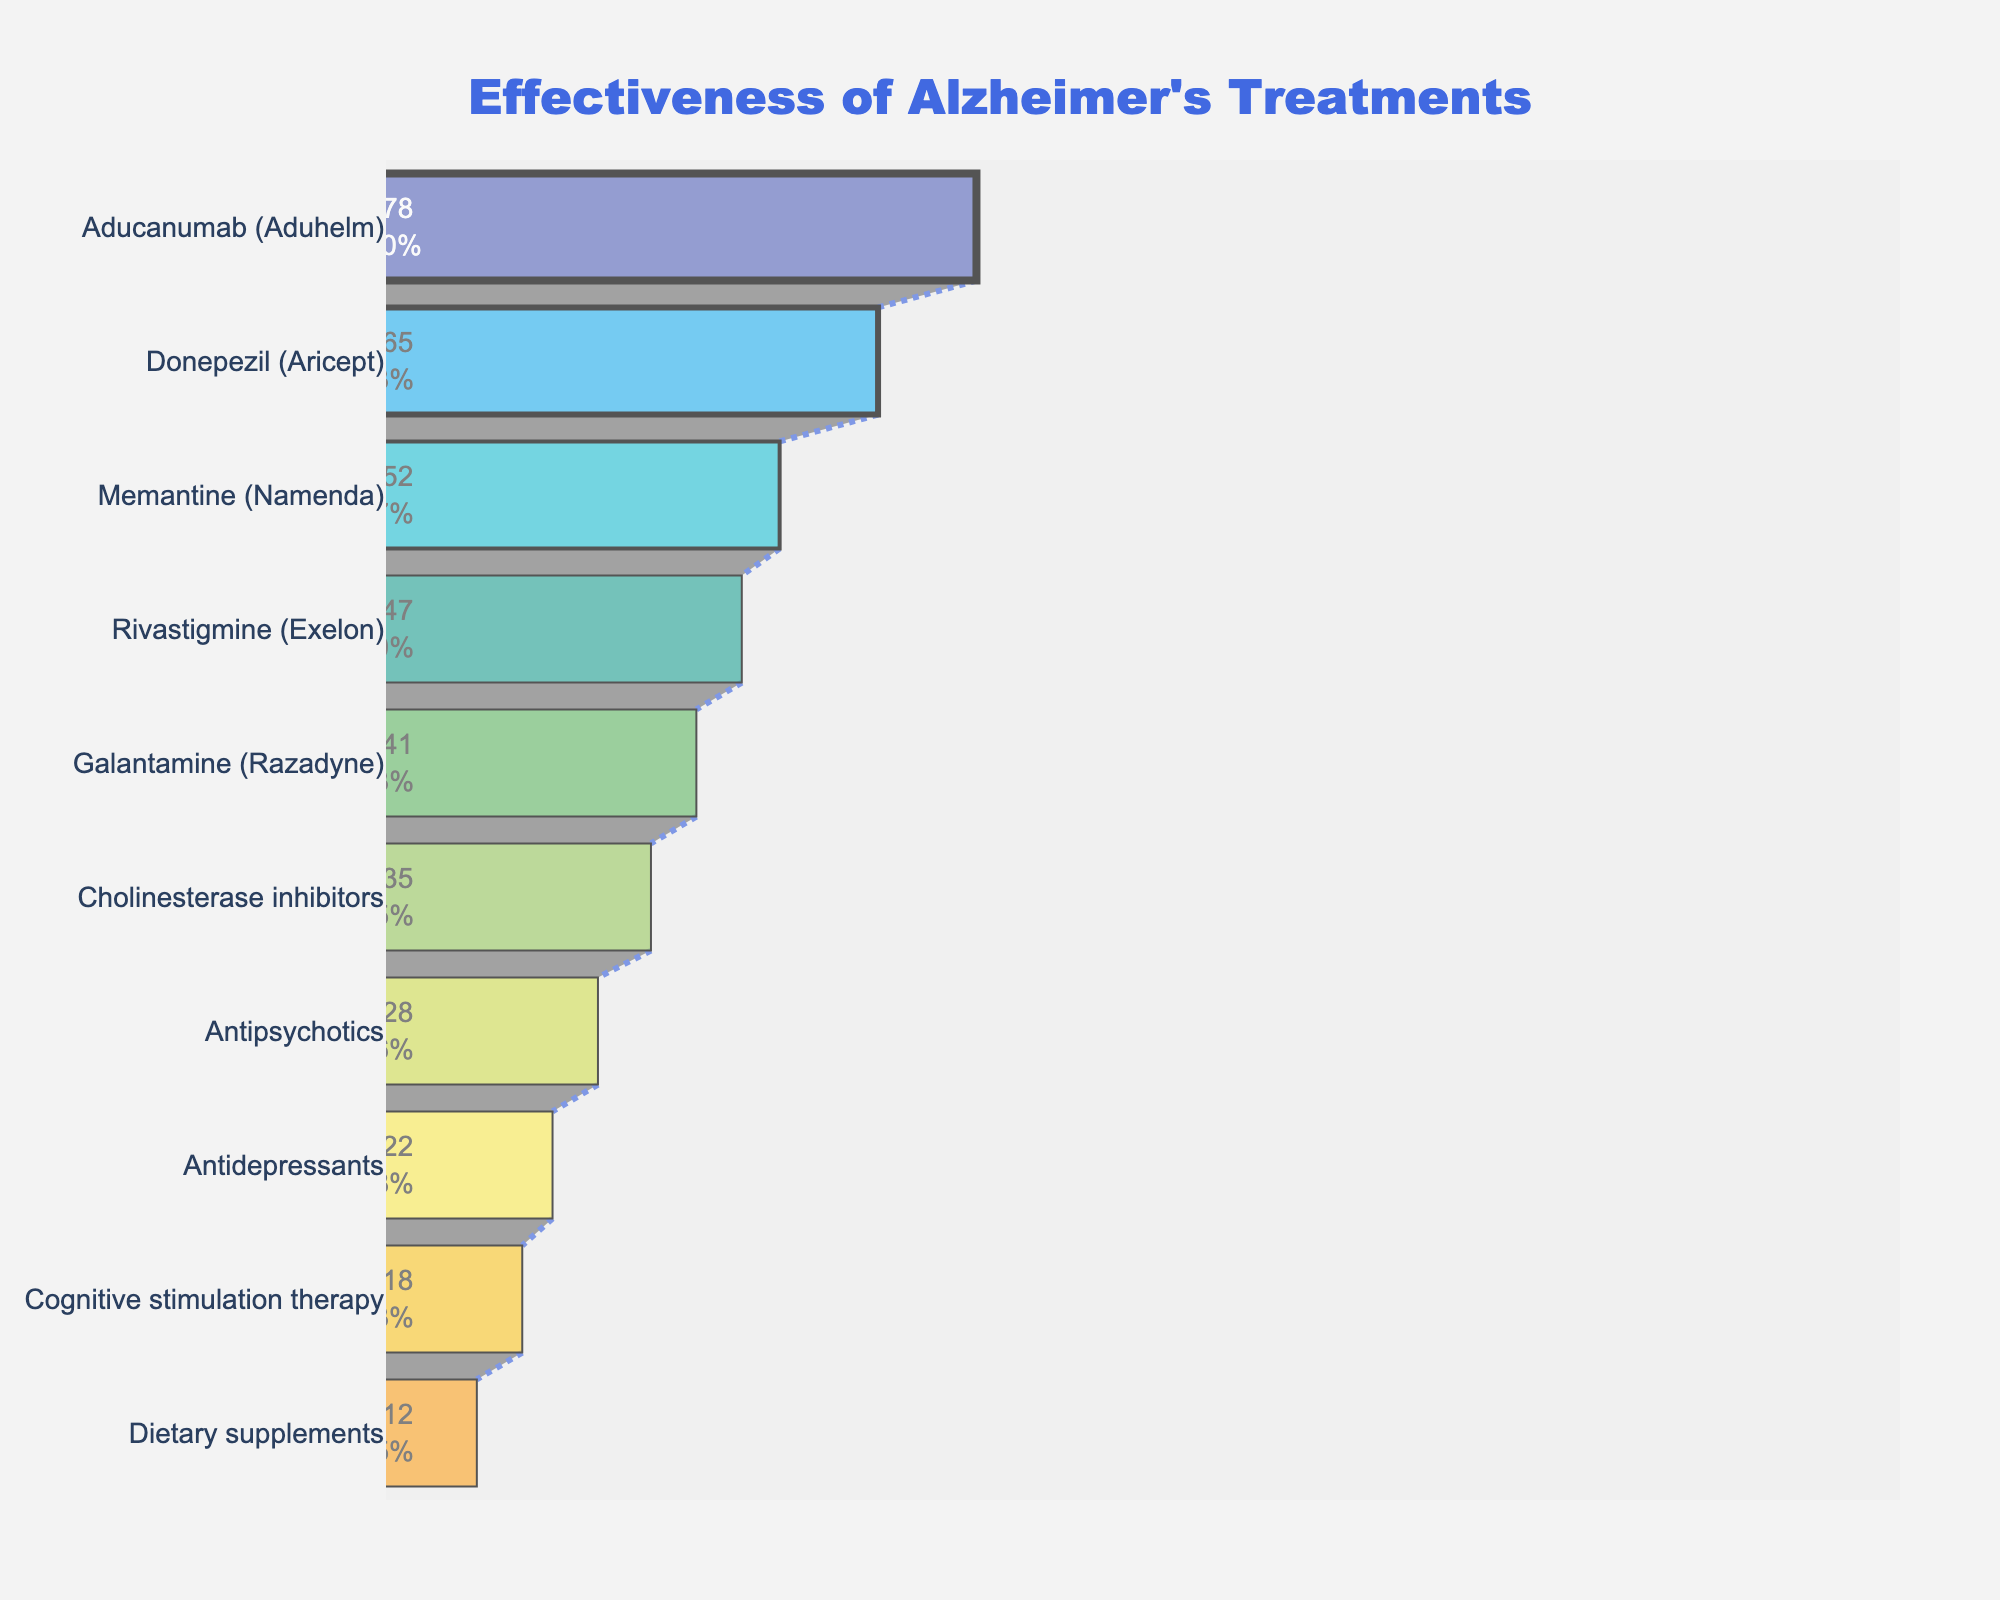Which Alzheimer's treatment has the highest success rate? The funnel chart shows the success rates of various Alzheimer's treatments, with the highest success rate at the top of the chart. Aducanumab (Aduhelm) is at the top.
Answer: Aducanumab (Aduhelm) What is the success rate of Donepezil (Aricept)? The funnel chart lists the success rates next to each treatment. Donepezil (Aricept) is the second treatment in the chart, with a success rate of 0.65 or 65%.
Answer: 65% How do the success rates of Memantine (Namenda) and Rivastigmine (Exelon) compare? By examining the chart, we can see Memantine (Namenda) has a success rate of 52% and Rivastigmine (Exelon) has a success rate of 47%. Comparing these values, Memantine has a higher success rate than Rivastigmine.
Answer: Memantine (Namenda) has a higher success rate Which treatments have a success rate of less than 30%? By scanning the funnel chart, treatments with success rates under 30% are Antipsychotics, Antidepressants, Cognitive stimulation therapy, and Dietary supplements.
Answer: Antipsychotics, Antidepressants, Cognitive stimulation therapy, Dietary supplements What is the difference in success rate between Galantamine (Razadyne) and Cholinesterase inhibitors? The success rate of Galantamine (Razadyne) is 41%, and Cholinesterase inhibitors is 35%. Subtracting these values gives the difference: 41% - 35% = 6%.
Answer: 6% Which treatment is ranked just below Donepezil (Aricept) based on success rate? In the funnel chart, Donepezil (Aricept) is followed by Memantine (Namenda), making it the treatment ranked just below Donepezil.
Answer: Memantine (Namenda) What percentage of treatments have a success rate higher than 0.50 (50%)? Treatments with success rates higher than 50% are Aducanumab (Aduhelm), Donepezil (Aricept), and Memantine (Namenda). Out of 10 treatments, 3 have success rates over 50%. Thus, 3/10 = 30%.
Answer: 30% How do the success rates of Cognitive stimulation therapy and Antidepressants compare? The chart shows Cognitive stimulation therapy with an 18% success rate and Antidepressants with a 22% success rate. Antidepressants have a higher success rate by 4%.
Answer: Antidepressants have a higher success rate What is the combined success rate of the top two treatments in the chart? The success rates of the top two treatments, Aducanumab (Aduhelm) and Donepezil (Aricept), are 78% and 65%. Adding these together gives: 78% + 65% = 143%.
Answer: 143% Which treatments have a success rate lower than 20%? Treatments with success rates below 20% are Cognitive stimulation therapy (18%) and Dietary supplements (12%).
Answer: Cognitive stimulation therapy, Dietary supplements 